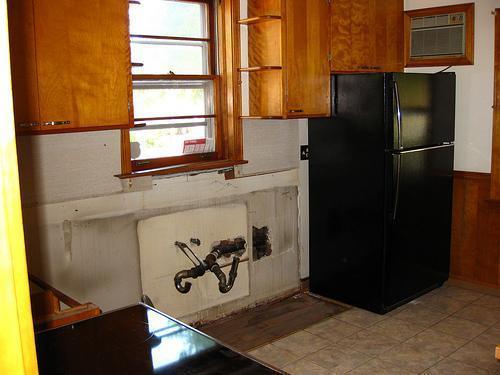How many people are visible?
Give a very brief answer. 0. 